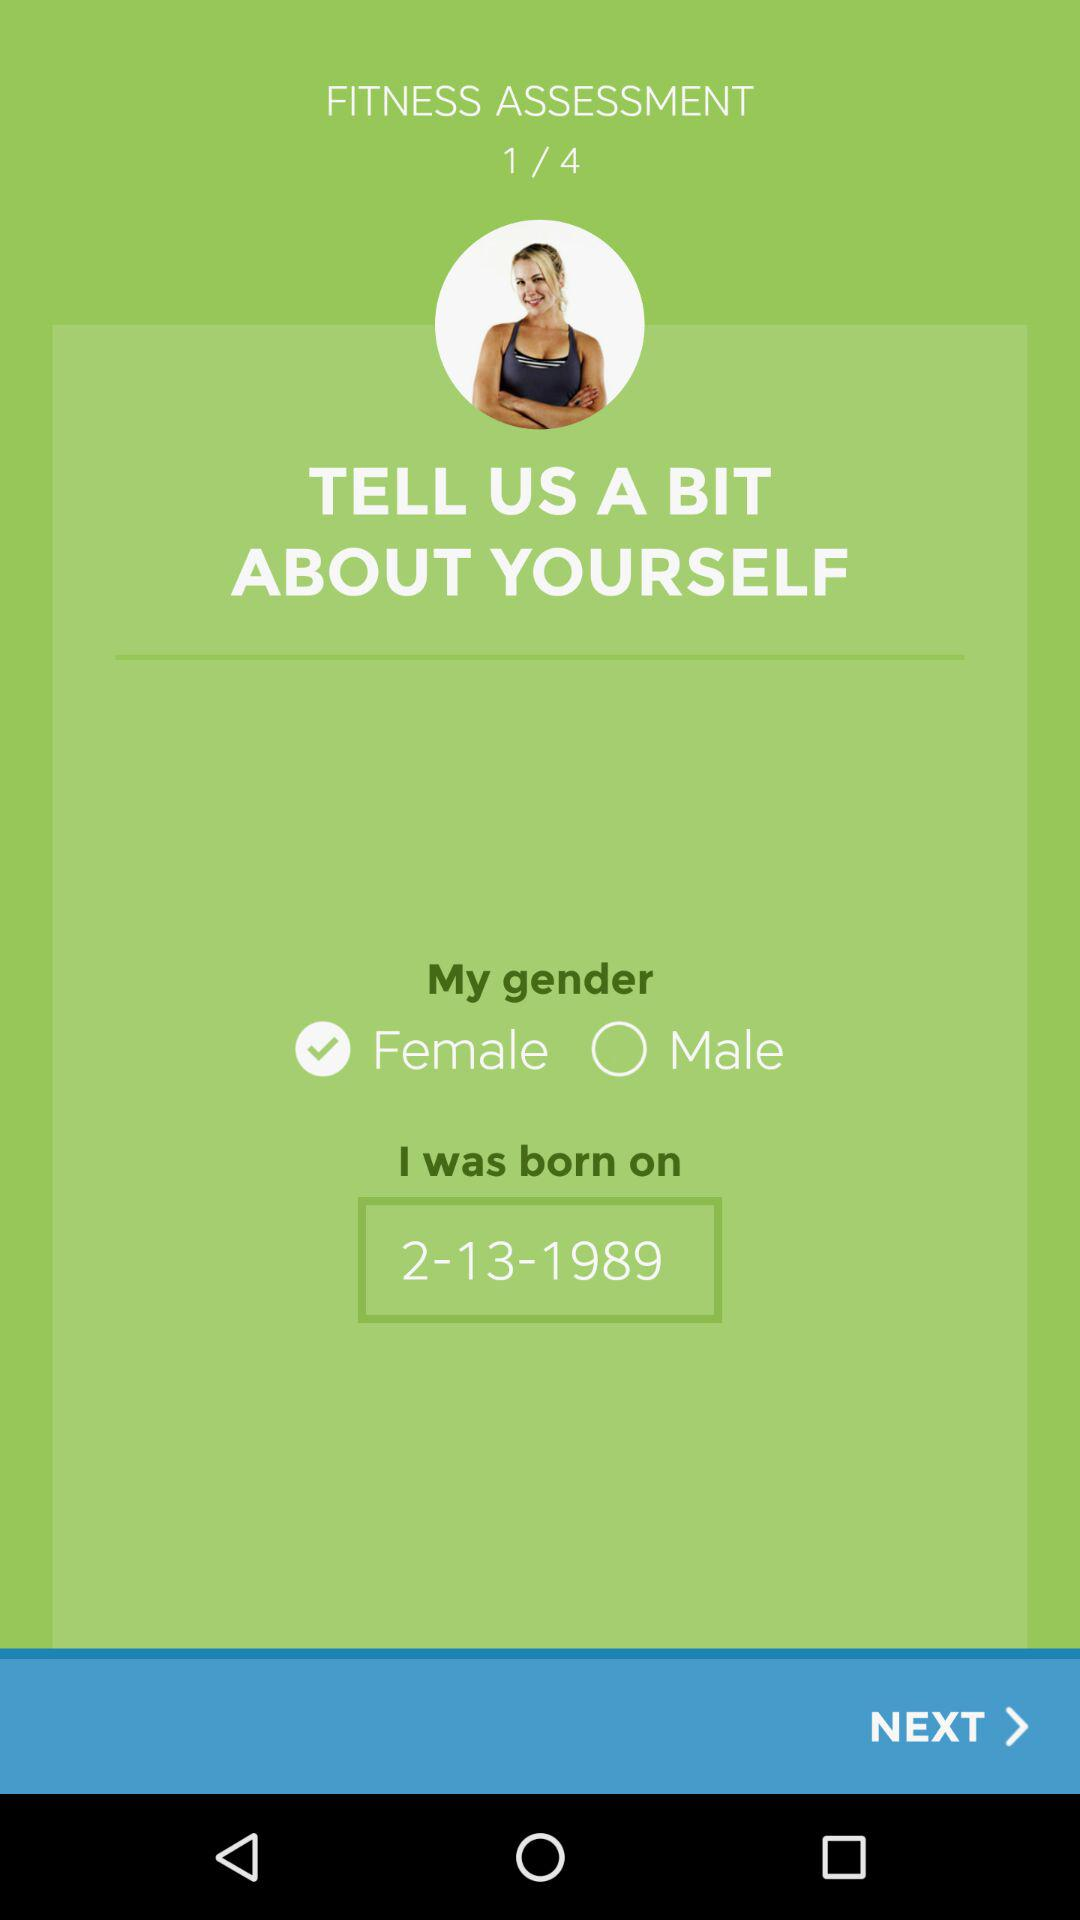How many sets are in the "Fitness assessment"? There are 4 sets. 